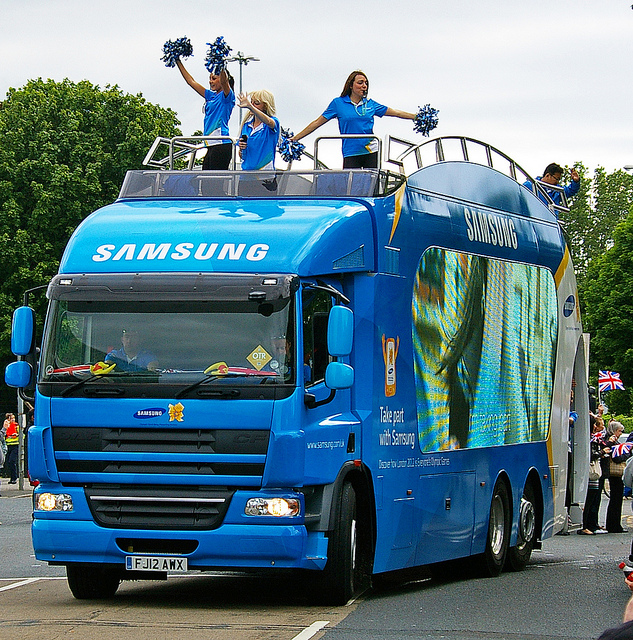Identify the text contained in this image. SAMSUNG SAMSUNG 